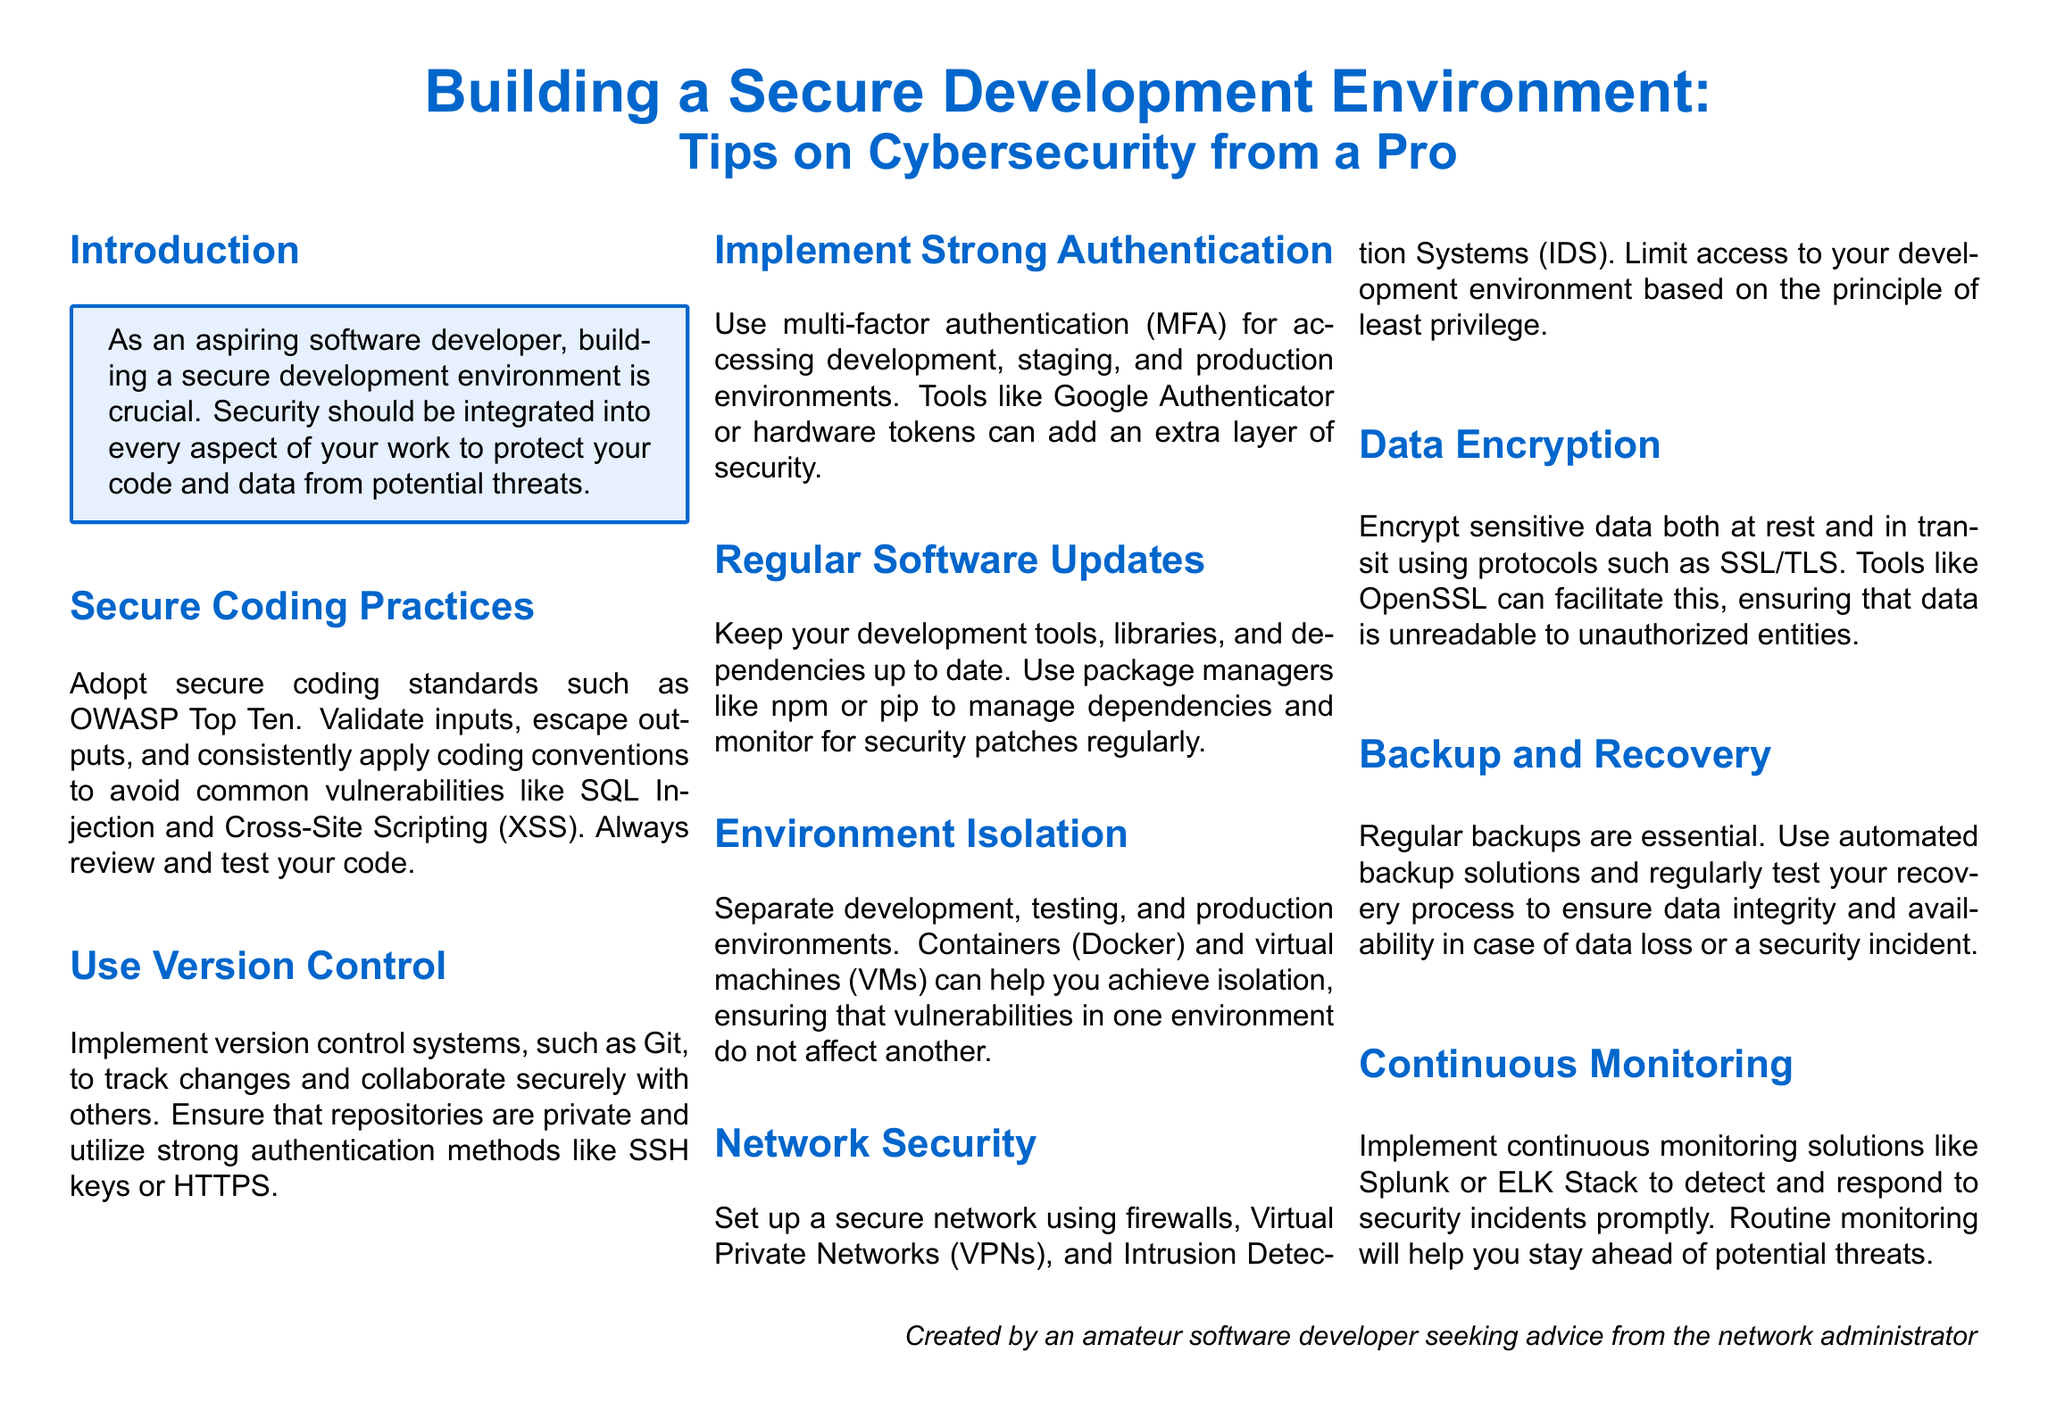What is the title of the document? The title of the document is typically found at the top and states the main topic of the content.
Answer: Building a Secure Development Environment Who is the intended audience for this document? The intended audience is usually indicated in the introduction or by the author's perspective.
Answer: Aspiring software developer What coding standards should be adopted? The document mentions specific guidelines that should be followed to ensure secure coding practices.
Answer: OWASP Top Ten What should be used for version control? The section discusses the tools or systems that can be utilized to manage changes in the code.
Answer: Git What is a recommended method for strong authentication? The document suggests a specific system to bolster security when accessing environments.
Answer: Multi-factor authentication Which encryption protocols are mentioned? The document lists specific protocols that should be utilized for securing data.
Answer: SSL/TLS What is necessary for regular backups? The document emphasizes a specific process or solution that should be in place for data protection.
Answer: Automated backup solutions Which monitoring tools are recommended? The document indicates the tools that help in continuously observing security incidents.
Answer: Splunk or ELK Stack How can development environments be isolated? The document introduces methods that can be used to prevent vulnerabilities from affecting multiple environments.
Answer: Containers (Docker) and virtual machines (VMs) What is emphasized for network security? The document outlines a strategy for ensuring the integrity and safety of the network used in development.
Answer: Firewalls 